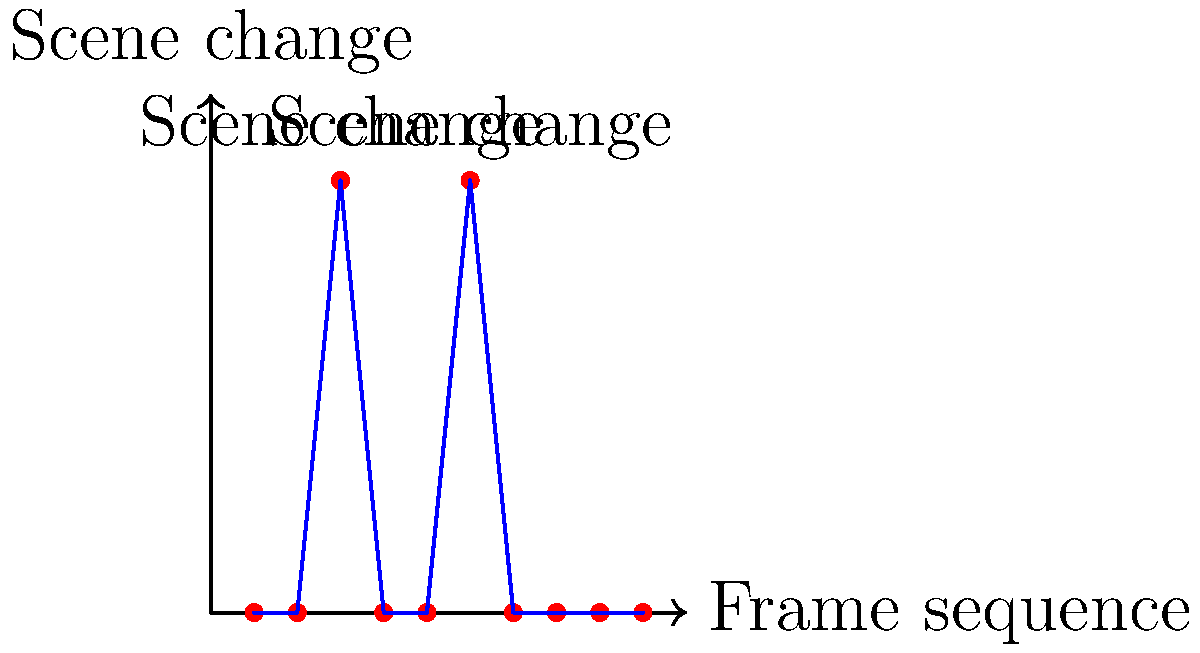In the graph above, which represents a frame sequence analysis of a music video, how many scene changes are detected, and at which frame sequence points do they occur? To analyze the scene changes in the music video using the frame sequence:

1. Observe the y-axis, which represents scene changes (0 for no change, 1 for a change).
2. Scan the graph from left to right, looking for points where the y-value is 1.
3. Count these points and note their corresponding x-values (frame sequence).

Step-by-step analysis:
1. First scene change: At frame sequence 0.3
2. Second scene change: At frame sequence 0.6
3. No other points reach y=1, so there are no more scene changes.

Therefore, there are 2 scene changes detected in total, occurring at frame sequence points 0.3 and 0.6.
Answer: 2 changes; at 0.3 and 0.6 